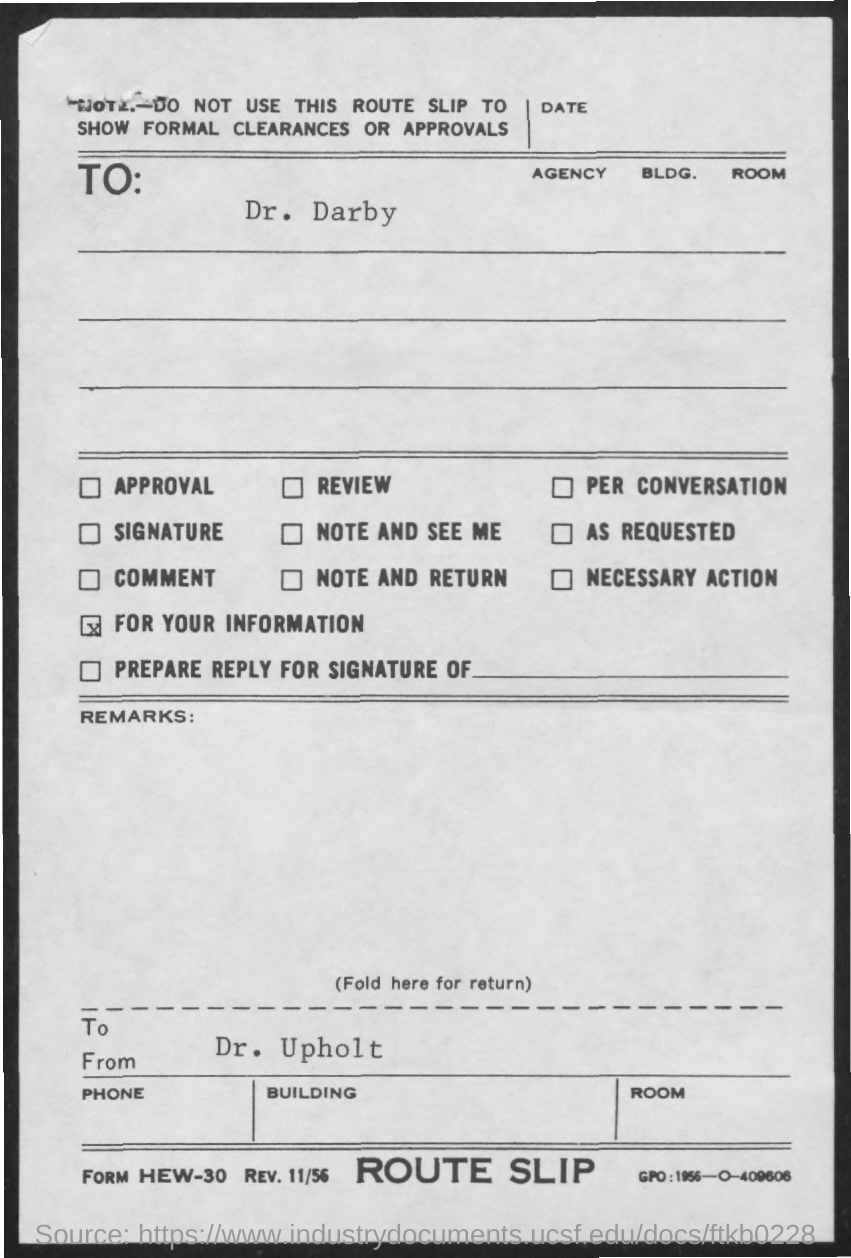Give some essential details in this illustration. The letter is from Dr. Upholt. The letter is addressed to Dr. Darby. 